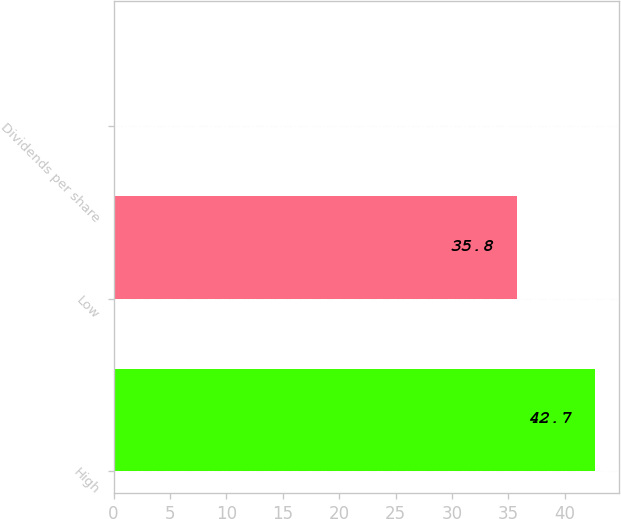<chart> <loc_0><loc_0><loc_500><loc_500><bar_chart><fcel>High<fcel>Low<fcel>Dividends per share<nl><fcel>42.7<fcel>35.8<fcel>0.1<nl></chart> 